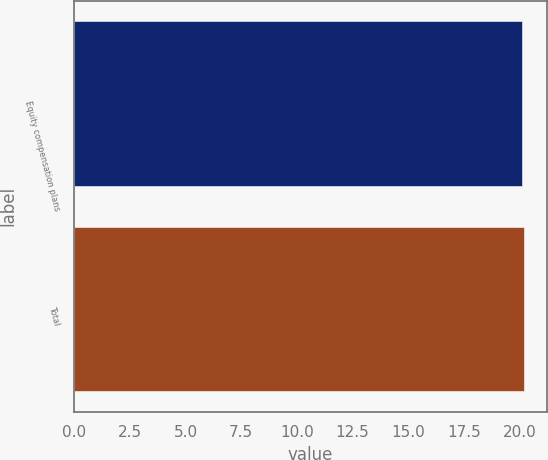Convert chart. <chart><loc_0><loc_0><loc_500><loc_500><bar_chart><fcel>Equity compensation plans<fcel>Total<nl><fcel>20.11<fcel>20.21<nl></chart> 